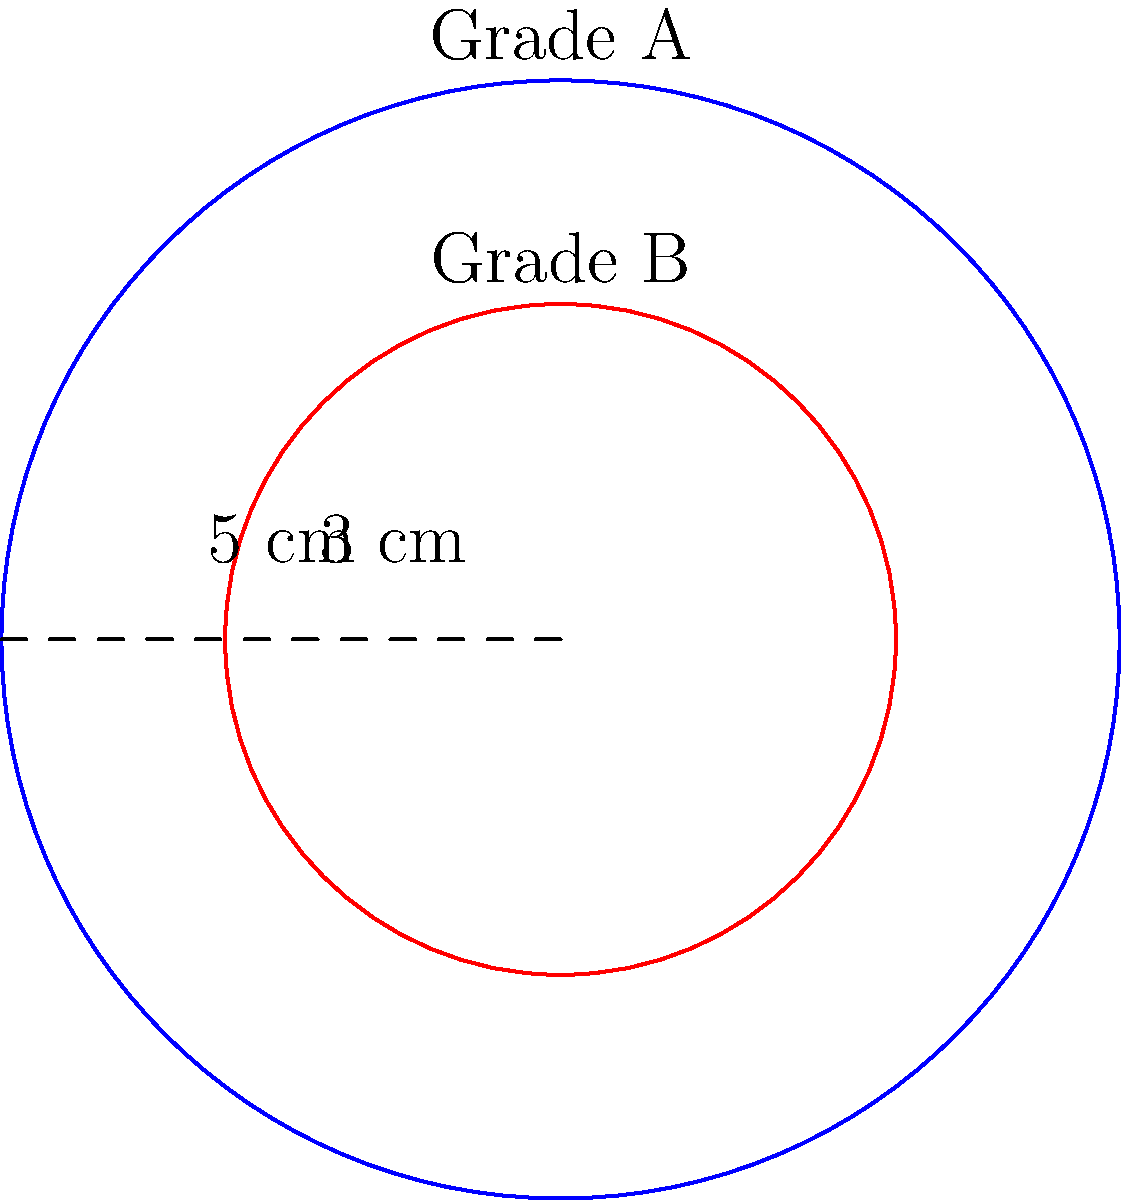As a materials procurement specialist, you're managing the supply of two grades of circular metal sheets for a machine operator. Grade A has a radius of 5 cm, while Grade B has a radius of 3 cm. What is the area of the region between these two grades of material? To find the area between two concentric circles, we need to:

1. Calculate the area of the larger circle (Grade A):
   $$A_A = \pi r_A^2 = \pi (5 \text{ cm})^2 = 25\pi \text{ cm}^2$$

2. Calculate the area of the smaller circle (Grade B):
   $$A_B = \pi r_B^2 = \pi (3 \text{ cm})^2 = 9\pi \text{ cm}^2$$

3. Subtract the area of the smaller circle from the larger circle:
   $$A_{\text{between}} = A_A - A_B = 25\pi \text{ cm}^2 - 9\pi \text{ cm}^2 = 16\pi \text{ cm}^2$$

Therefore, the area of the region between the two grades of material is $16\pi \text{ cm}^2$.
Answer: $16\pi \text{ cm}^2$ 